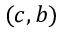<formula> <loc_0><loc_0><loc_500><loc_500>( c , b )</formula> 